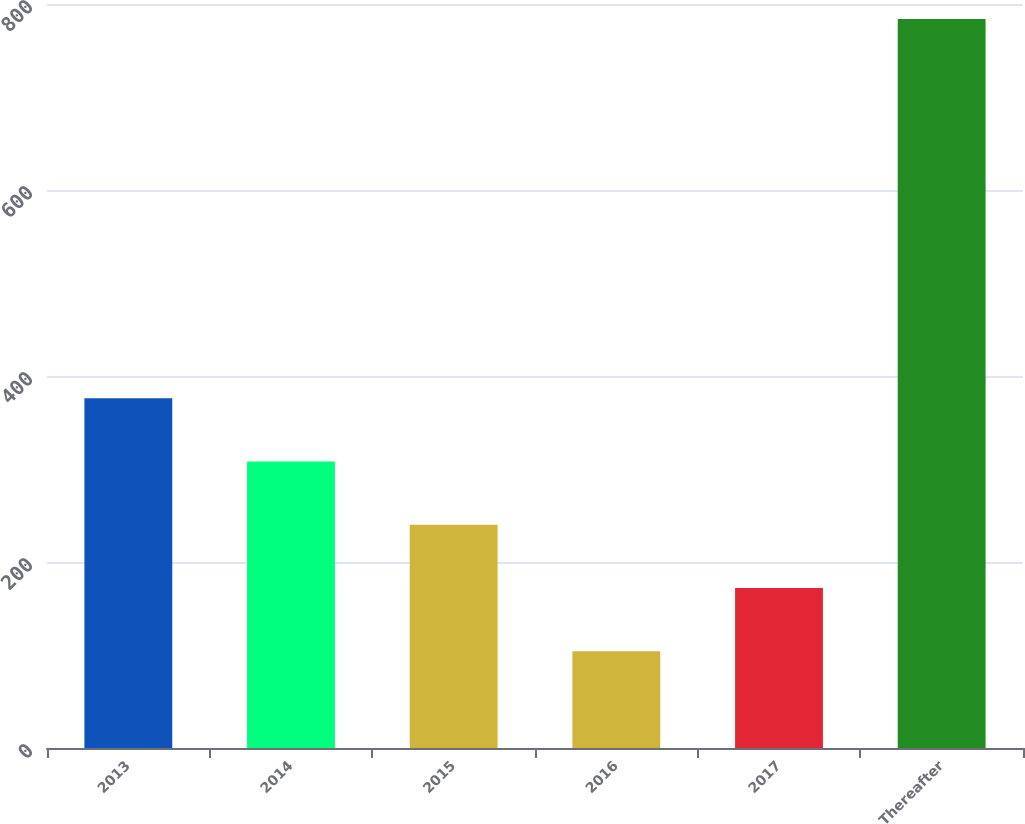Convert chart to OTSL. <chart><loc_0><loc_0><loc_500><loc_500><bar_chart><fcel>2013<fcel>2014<fcel>2015<fcel>2016<fcel>2017<fcel>Thereafter<nl><fcel>376<fcel>308<fcel>240<fcel>104<fcel>172<fcel>784<nl></chart> 